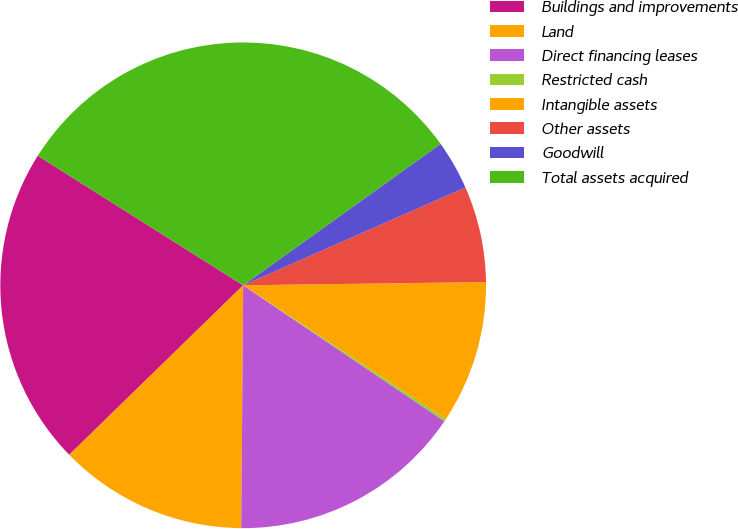<chart> <loc_0><loc_0><loc_500><loc_500><pie_chart><fcel>Buildings and improvements<fcel>Land<fcel>Direct financing leases<fcel>Restricted cash<fcel>Intangible assets<fcel>Other assets<fcel>Goodwill<fcel>Total assets acquired<nl><fcel>21.25%<fcel>12.58%<fcel>15.67%<fcel>0.19%<fcel>9.48%<fcel>6.39%<fcel>3.29%<fcel>31.15%<nl></chart> 